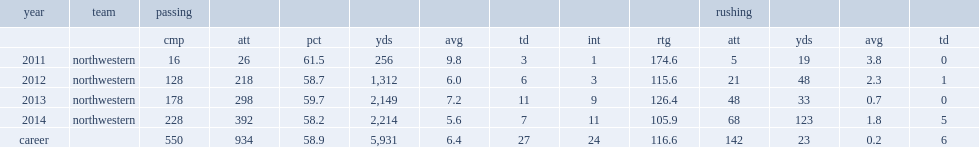How many passing yards did siemian have in his career at northwestern? 5931.0. 